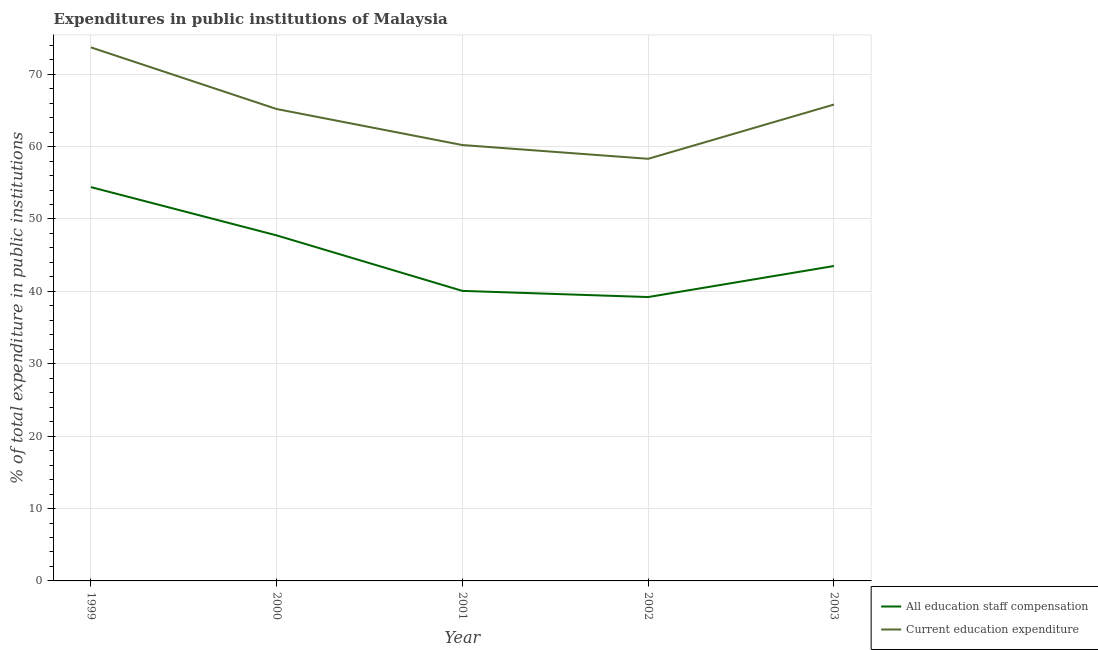How many different coloured lines are there?
Ensure brevity in your answer.  2. What is the expenditure in staff compensation in 2002?
Keep it short and to the point. 39.22. Across all years, what is the maximum expenditure in education?
Keep it short and to the point. 73.71. Across all years, what is the minimum expenditure in staff compensation?
Provide a short and direct response. 39.22. In which year was the expenditure in education maximum?
Keep it short and to the point. 1999. What is the total expenditure in education in the graph?
Ensure brevity in your answer.  323.23. What is the difference between the expenditure in education in 2001 and that in 2003?
Offer a terse response. -5.6. What is the difference between the expenditure in education in 1999 and the expenditure in staff compensation in 2000?
Provide a short and direct response. 25.98. What is the average expenditure in education per year?
Offer a very short reply. 64.65. In the year 2000, what is the difference between the expenditure in education and expenditure in staff compensation?
Your answer should be compact. 17.46. What is the ratio of the expenditure in education in 1999 to that in 2003?
Your answer should be compact. 1.12. Is the expenditure in staff compensation in 1999 less than that in 2003?
Ensure brevity in your answer.  No. Is the difference between the expenditure in staff compensation in 1999 and 2002 greater than the difference between the expenditure in education in 1999 and 2002?
Provide a short and direct response. No. What is the difference between the highest and the second highest expenditure in staff compensation?
Provide a succinct answer. 6.67. What is the difference between the highest and the lowest expenditure in staff compensation?
Your response must be concise. 15.19. Is the sum of the expenditure in staff compensation in 1999 and 2000 greater than the maximum expenditure in education across all years?
Your answer should be compact. Yes. Does the expenditure in staff compensation monotonically increase over the years?
Your answer should be compact. No. Is the expenditure in education strictly less than the expenditure in staff compensation over the years?
Your response must be concise. No. How many years are there in the graph?
Offer a very short reply. 5. What is the difference between two consecutive major ticks on the Y-axis?
Ensure brevity in your answer.  10. Does the graph contain any zero values?
Offer a very short reply. No. Does the graph contain grids?
Your response must be concise. Yes. Where does the legend appear in the graph?
Give a very brief answer. Bottom right. How many legend labels are there?
Keep it short and to the point. 2. How are the legend labels stacked?
Give a very brief answer. Vertical. What is the title of the graph?
Ensure brevity in your answer.  Expenditures in public institutions of Malaysia. What is the label or title of the Y-axis?
Provide a succinct answer. % of total expenditure in public institutions. What is the % of total expenditure in public institutions of All education staff compensation in 1999?
Provide a short and direct response. 54.4. What is the % of total expenditure in public institutions in Current education expenditure in 1999?
Provide a succinct answer. 73.71. What is the % of total expenditure in public institutions of All education staff compensation in 2000?
Give a very brief answer. 47.73. What is the % of total expenditure in public institutions of Current education expenditure in 2000?
Your answer should be very brief. 65.19. What is the % of total expenditure in public institutions in All education staff compensation in 2001?
Provide a succinct answer. 40.07. What is the % of total expenditure in public institutions of Current education expenditure in 2001?
Ensure brevity in your answer.  60.21. What is the % of total expenditure in public institutions in All education staff compensation in 2002?
Ensure brevity in your answer.  39.22. What is the % of total expenditure in public institutions of Current education expenditure in 2002?
Your answer should be compact. 58.31. What is the % of total expenditure in public institutions in All education staff compensation in 2003?
Provide a short and direct response. 43.5. What is the % of total expenditure in public institutions in Current education expenditure in 2003?
Your response must be concise. 65.81. Across all years, what is the maximum % of total expenditure in public institutions in All education staff compensation?
Make the answer very short. 54.4. Across all years, what is the maximum % of total expenditure in public institutions in Current education expenditure?
Provide a succinct answer. 73.71. Across all years, what is the minimum % of total expenditure in public institutions of All education staff compensation?
Your answer should be very brief. 39.22. Across all years, what is the minimum % of total expenditure in public institutions of Current education expenditure?
Provide a succinct answer. 58.31. What is the total % of total expenditure in public institutions in All education staff compensation in the graph?
Provide a short and direct response. 224.92. What is the total % of total expenditure in public institutions of Current education expenditure in the graph?
Make the answer very short. 323.23. What is the difference between the % of total expenditure in public institutions of All education staff compensation in 1999 and that in 2000?
Give a very brief answer. 6.67. What is the difference between the % of total expenditure in public institutions in Current education expenditure in 1999 and that in 2000?
Offer a terse response. 8.52. What is the difference between the % of total expenditure in public institutions of All education staff compensation in 1999 and that in 2001?
Your answer should be very brief. 14.34. What is the difference between the % of total expenditure in public institutions of Current education expenditure in 1999 and that in 2001?
Make the answer very short. 13.49. What is the difference between the % of total expenditure in public institutions in All education staff compensation in 1999 and that in 2002?
Provide a short and direct response. 15.19. What is the difference between the % of total expenditure in public institutions of Current education expenditure in 1999 and that in 2002?
Provide a short and direct response. 15.4. What is the difference between the % of total expenditure in public institutions of All education staff compensation in 1999 and that in 2003?
Ensure brevity in your answer.  10.9. What is the difference between the % of total expenditure in public institutions in Current education expenditure in 1999 and that in 2003?
Give a very brief answer. 7.9. What is the difference between the % of total expenditure in public institutions of All education staff compensation in 2000 and that in 2001?
Your response must be concise. 7.67. What is the difference between the % of total expenditure in public institutions of Current education expenditure in 2000 and that in 2001?
Offer a very short reply. 4.97. What is the difference between the % of total expenditure in public institutions of All education staff compensation in 2000 and that in 2002?
Provide a succinct answer. 8.52. What is the difference between the % of total expenditure in public institutions of Current education expenditure in 2000 and that in 2002?
Your response must be concise. 6.88. What is the difference between the % of total expenditure in public institutions of All education staff compensation in 2000 and that in 2003?
Ensure brevity in your answer.  4.23. What is the difference between the % of total expenditure in public institutions of Current education expenditure in 2000 and that in 2003?
Your response must be concise. -0.62. What is the difference between the % of total expenditure in public institutions in All education staff compensation in 2001 and that in 2002?
Your answer should be compact. 0.85. What is the difference between the % of total expenditure in public institutions of Current education expenditure in 2001 and that in 2002?
Your answer should be compact. 1.9. What is the difference between the % of total expenditure in public institutions of All education staff compensation in 2001 and that in 2003?
Your answer should be compact. -3.44. What is the difference between the % of total expenditure in public institutions of Current education expenditure in 2001 and that in 2003?
Offer a very short reply. -5.6. What is the difference between the % of total expenditure in public institutions in All education staff compensation in 2002 and that in 2003?
Make the answer very short. -4.29. What is the difference between the % of total expenditure in public institutions of Current education expenditure in 2002 and that in 2003?
Ensure brevity in your answer.  -7.5. What is the difference between the % of total expenditure in public institutions of All education staff compensation in 1999 and the % of total expenditure in public institutions of Current education expenditure in 2000?
Provide a succinct answer. -10.78. What is the difference between the % of total expenditure in public institutions of All education staff compensation in 1999 and the % of total expenditure in public institutions of Current education expenditure in 2001?
Provide a succinct answer. -5.81. What is the difference between the % of total expenditure in public institutions in All education staff compensation in 1999 and the % of total expenditure in public institutions in Current education expenditure in 2002?
Provide a short and direct response. -3.91. What is the difference between the % of total expenditure in public institutions in All education staff compensation in 1999 and the % of total expenditure in public institutions in Current education expenditure in 2003?
Your response must be concise. -11.41. What is the difference between the % of total expenditure in public institutions in All education staff compensation in 2000 and the % of total expenditure in public institutions in Current education expenditure in 2001?
Offer a terse response. -12.48. What is the difference between the % of total expenditure in public institutions in All education staff compensation in 2000 and the % of total expenditure in public institutions in Current education expenditure in 2002?
Make the answer very short. -10.58. What is the difference between the % of total expenditure in public institutions in All education staff compensation in 2000 and the % of total expenditure in public institutions in Current education expenditure in 2003?
Offer a very short reply. -18.08. What is the difference between the % of total expenditure in public institutions in All education staff compensation in 2001 and the % of total expenditure in public institutions in Current education expenditure in 2002?
Provide a short and direct response. -18.25. What is the difference between the % of total expenditure in public institutions in All education staff compensation in 2001 and the % of total expenditure in public institutions in Current education expenditure in 2003?
Provide a succinct answer. -25.75. What is the difference between the % of total expenditure in public institutions of All education staff compensation in 2002 and the % of total expenditure in public institutions of Current education expenditure in 2003?
Your answer should be compact. -26.59. What is the average % of total expenditure in public institutions of All education staff compensation per year?
Offer a very short reply. 44.98. What is the average % of total expenditure in public institutions of Current education expenditure per year?
Your answer should be very brief. 64.65. In the year 1999, what is the difference between the % of total expenditure in public institutions in All education staff compensation and % of total expenditure in public institutions in Current education expenditure?
Ensure brevity in your answer.  -19.3. In the year 2000, what is the difference between the % of total expenditure in public institutions in All education staff compensation and % of total expenditure in public institutions in Current education expenditure?
Give a very brief answer. -17.46. In the year 2001, what is the difference between the % of total expenditure in public institutions of All education staff compensation and % of total expenditure in public institutions of Current education expenditure?
Provide a short and direct response. -20.15. In the year 2002, what is the difference between the % of total expenditure in public institutions of All education staff compensation and % of total expenditure in public institutions of Current education expenditure?
Give a very brief answer. -19.1. In the year 2003, what is the difference between the % of total expenditure in public institutions of All education staff compensation and % of total expenditure in public institutions of Current education expenditure?
Your response must be concise. -22.31. What is the ratio of the % of total expenditure in public institutions of All education staff compensation in 1999 to that in 2000?
Give a very brief answer. 1.14. What is the ratio of the % of total expenditure in public institutions of Current education expenditure in 1999 to that in 2000?
Make the answer very short. 1.13. What is the ratio of the % of total expenditure in public institutions in All education staff compensation in 1999 to that in 2001?
Make the answer very short. 1.36. What is the ratio of the % of total expenditure in public institutions of Current education expenditure in 1999 to that in 2001?
Your response must be concise. 1.22. What is the ratio of the % of total expenditure in public institutions in All education staff compensation in 1999 to that in 2002?
Your response must be concise. 1.39. What is the ratio of the % of total expenditure in public institutions in Current education expenditure in 1999 to that in 2002?
Ensure brevity in your answer.  1.26. What is the ratio of the % of total expenditure in public institutions in All education staff compensation in 1999 to that in 2003?
Keep it short and to the point. 1.25. What is the ratio of the % of total expenditure in public institutions in Current education expenditure in 1999 to that in 2003?
Make the answer very short. 1.12. What is the ratio of the % of total expenditure in public institutions of All education staff compensation in 2000 to that in 2001?
Provide a short and direct response. 1.19. What is the ratio of the % of total expenditure in public institutions of Current education expenditure in 2000 to that in 2001?
Your answer should be very brief. 1.08. What is the ratio of the % of total expenditure in public institutions in All education staff compensation in 2000 to that in 2002?
Provide a short and direct response. 1.22. What is the ratio of the % of total expenditure in public institutions in Current education expenditure in 2000 to that in 2002?
Offer a very short reply. 1.12. What is the ratio of the % of total expenditure in public institutions in All education staff compensation in 2000 to that in 2003?
Your response must be concise. 1.1. What is the ratio of the % of total expenditure in public institutions of Current education expenditure in 2000 to that in 2003?
Your answer should be compact. 0.99. What is the ratio of the % of total expenditure in public institutions in All education staff compensation in 2001 to that in 2002?
Your response must be concise. 1.02. What is the ratio of the % of total expenditure in public institutions of Current education expenditure in 2001 to that in 2002?
Provide a succinct answer. 1.03. What is the ratio of the % of total expenditure in public institutions of All education staff compensation in 2001 to that in 2003?
Your answer should be very brief. 0.92. What is the ratio of the % of total expenditure in public institutions of Current education expenditure in 2001 to that in 2003?
Ensure brevity in your answer.  0.91. What is the ratio of the % of total expenditure in public institutions of All education staff compensation in 2002 to that in 2003?
Offer a very short reply. 0.9. What is the ratio of the % of total expenditure in public institutions of Current education expenditure in 2002 to that in 2003?
Offer a very short reply. 0.89. What is the difference between the highest and the second highest % of total expenditure in public institutions of All education staff compensation?
Offer a very short reply. 6.67. What is the difference between the highest and the second highest % of total expenditure in public institutions of Current education expenditure?
Give a very brief answer. 7.9. What is the difference between the highest and the lowest % of total expenditure in public institutions in All education staff compensation?
Your response must be concise. 15.19. What is the difference between the highest and the lowest % of total expenditure in public institutions of Current education expenditure?
Your answer should be compact. 15.4. 